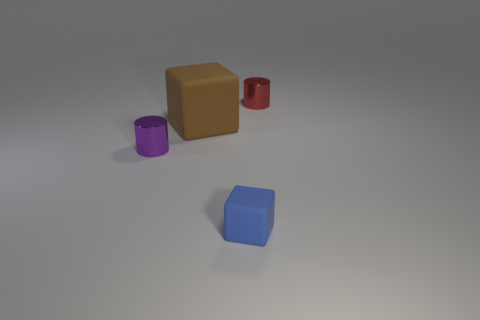Add 2 big brown matte objects. How many objects exist? 6 Add 4 small metallic cylinders. How many small metallic cylinders are left? 6 Add 3 tiny cubes. How many tiny cubes exist? 4 Subtract 0 red cubes. How many objects are left? 4 Subtract all brown matte cubes. Subtract all big brown cubes. How many objects are left? 2 